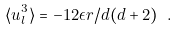Convert formula to latex. <formula><loc_0><loc_0><loc_500><loc_500>\langle u _ { l } ^ { 3 } \rangle = - 1 2 \epsilon r / d ( d + 2 ) \ .</formula> 